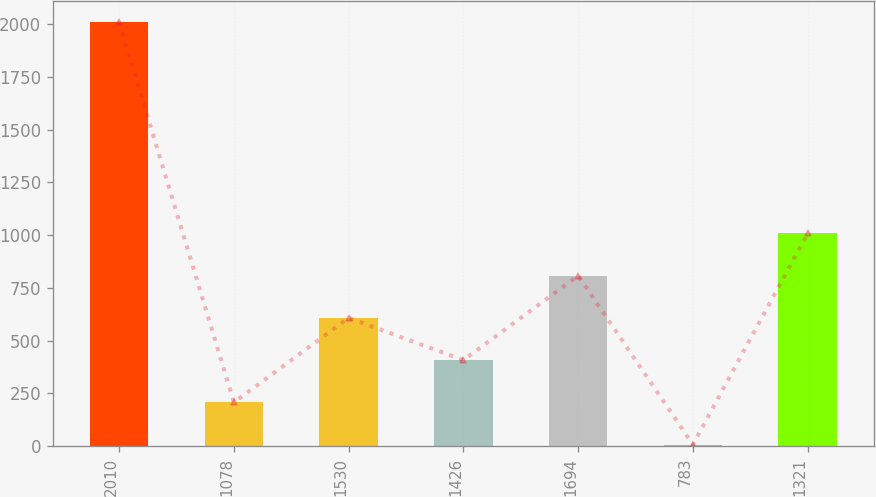Convert chart to OTSL. <chart><loc_0><loc_0><loc_500><loc_500><bar_chart><fcel>2010<fcel>1078<fcel>1530<fcel>1426<fcel>1694<fcel>783<fcel>1321<nl><fcel>2009<fcel>207.54<fcel>607.86<fcel>407.7<fcel>808.02<fcel>7.38<fcel>1008.18<nl></chart> 